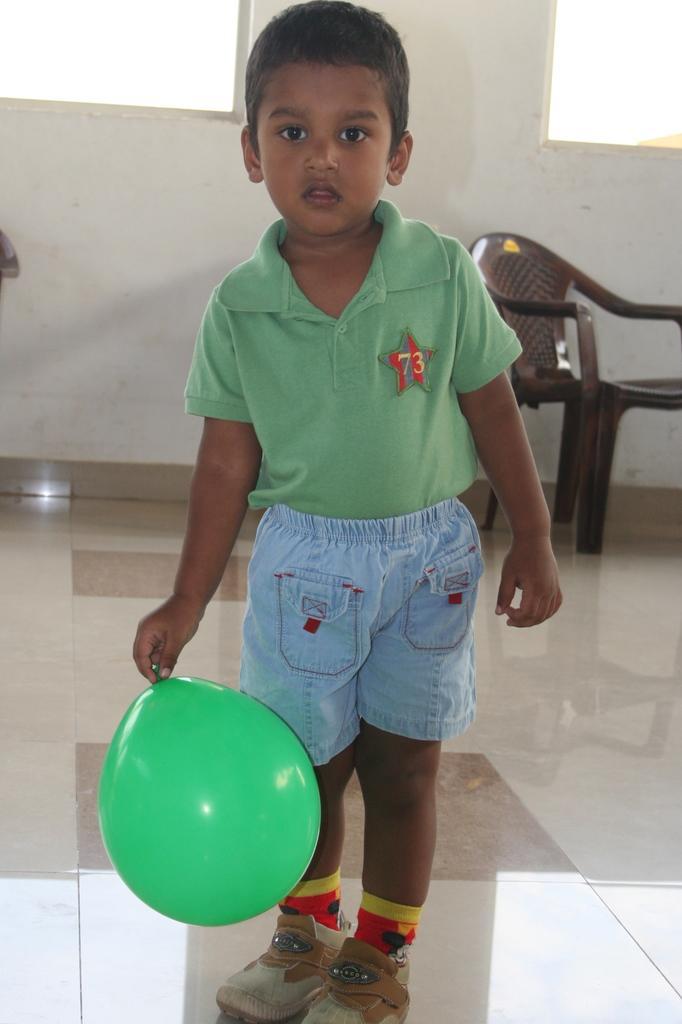Could you give a brief overview of what you see in this image? In this image I can see a boy is standing and holding a green color of balloon. In the background I can see a chair. 